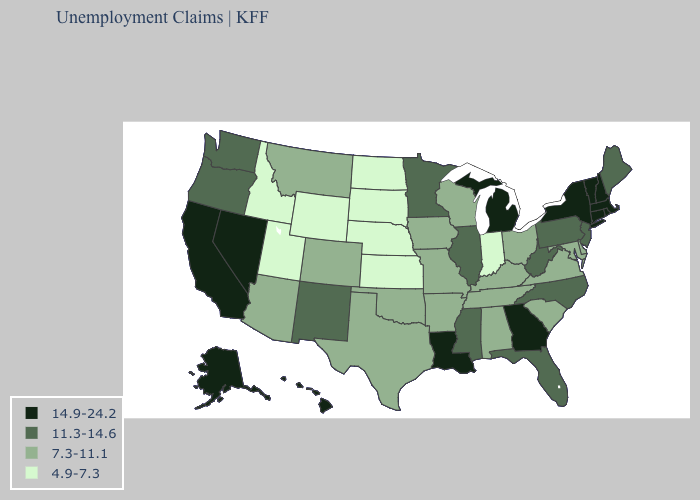Name the states that have a value in the range 11.3-14.6?
Answer briefly. Florida, Illinois, Maine, Minnesota, Mississippi, New Jersey, New Mexico, North Carolina, Oregon, Pennsylvania, Washington, West Virginia. Which states have the lowest value in the West?
Short answer required. Idaho, Utah, Wyoming. Name the states that have a value in the range 4.9-7.3?
Concise answer only. Idaho, Indiana, Kansas, Nebraska, North Dakota, South Dakota, Utah, Wyoming. What is the value of North Dakota?
Be succinct. 4.9-7.3. What is the value of Colorado?
Write a very short answer. 7.3-11.1. Name the states that have a value in the range 7.3-11.1?
Keep it brief. Alabama, Arizona, Arkansas, Colorado, Delaware, Iowa, Kentucky, Maryland, Missouri, Montana, Ohio, Oklahoma, South Carolina, Tennessee, Texas, Virginia, Wisconsin. What is the value of Arizona?
Concise answer only. 7.3-11.1. What is the value of Vermont?
Concise answer only. 14.9-24.2. Which states hav the highest value in the West?
Be succinct. Alaska, California, Hawaii, Nevada. Name the states that have a value in the range 4.9-7.3?
Write a very short answer. Idaho, Indiana, Kansas, Nebraska, North Dakota, South Dakota, Utah, Wyoming. Among the states that border California , does Arizona have the lowest value?
Write a very short answer. Yes. Name the states that have a value in the range 4.9-7.3?
Give a very brief answer. Idaho, Indiana, Kansas, Nebraska, North Dakota, South Dakota, Utah, Wyoming. Does Nevada have a lower value than Washington?
Keep it brief. No. Does Illinois have the highest value in the USA?
Write a very short answer. No. 